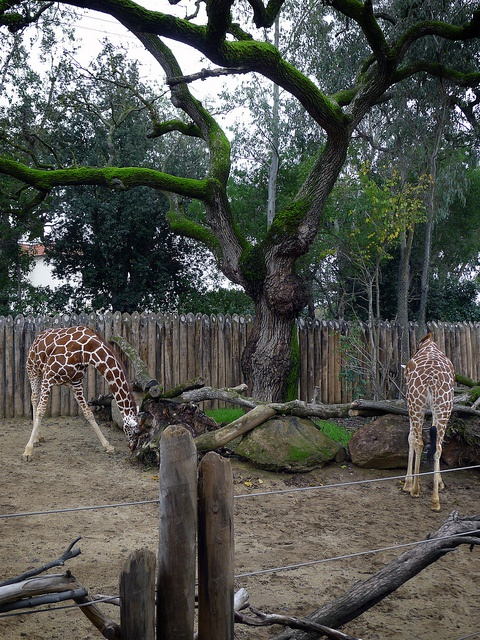Describe the objects in this image and their specific colors. I can see giraffe in darkgreen, gray, maroon, darkgray, and black tones and giraffe in darkgreen, gray, darkgray, and black tones in this image. 